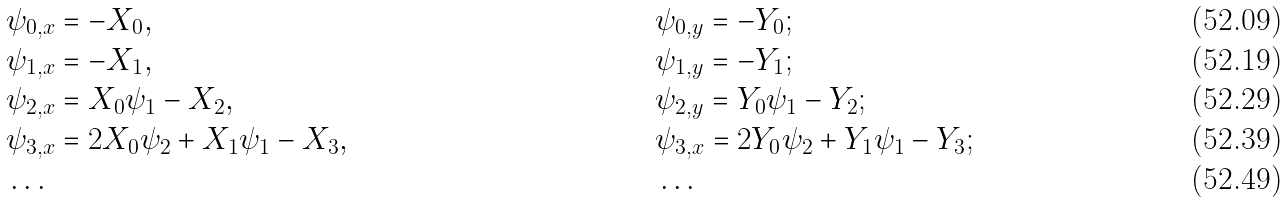Convert formula to latex. <formula><loc_0><loc_0><loc_500><loc_500>& \psi _ { 0 , x } = - X _ { 0 } , & & \psi _ { 0 , y } = - Y _ { 0 } ; \\ & \psi _ { 1 , x } = - X _ { 1 } , & & \psi _ { 1 , y } = - Y _ { 1 } ; \\ & \psi _ { 2 , x } = X _ { 0 } \psi _ { 1 } - X _ { 2 } , & & \psi _ { 2 , y } = Y _ { 0 } \psi _ { 1 } - Y _ { 2 } ; \\ & \psi _ { 3 , x } = 2 X _ { 0 } \psi _ { 2 } + X _ { 1 } \psi _ { 1 } - X _ { 3 } , & & \psi _ { 3 , x } = 2 Y _ { 0 } \psi _ { 2 } + Y _ { 1 } \psi _ { 1 } - Y _ { 3 } ; \\ & \dots & & \dots</formula> 